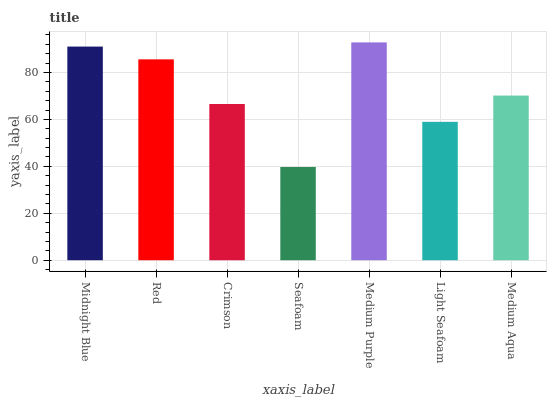Is Seafoam the minimum?
Answer yes or no. Yes. Is Medium Purple the maximum?
Answer yes or no. Yes. Is Red the minimum?
Answer yes or no. No. Is Red the maximum?
Answer yes or no. No. Is Midnight Blue greater than Red?
Answer yes or no. Yes. Is Red less than Midnight Blue?
Answer yes or no. Yes. Is Red greater than Midnight Blue?
Answer yes or no. No. Is Midnight Blue less than Red?
Answer yes or no. No. Is Medium Aqua the high median?
Answer yes or no. Yes. Is Medium Aqua the low median?
Answer yes or no. Yes. Is Crimson the high median?
Answer yes or no. No. Is Red the low median?
Answer yes or no. No. 